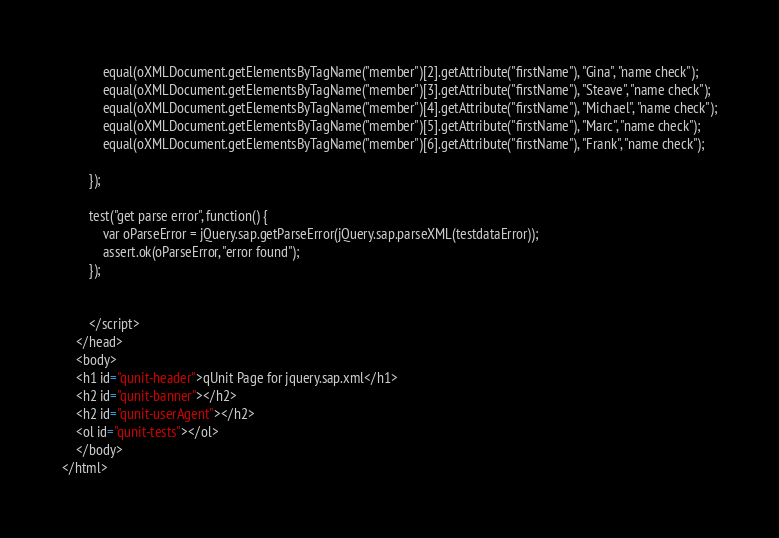<code> <loc_0><loc_0><loc_500><loc_500><_HTML_>			equal(oXMLDocument.getElementsByTagName("member")[2].getAttribute("firstName"), "Gina", "name check");
			equal(oXMLDocument.getElementsByTagName("member")[3].getAttribute("firstName"), "Steave", "name check");
			equal(oXMLDocument.getElementsByTagName("member")[4].getAttribute("firstName"), "Michael", "name check");
			equal(oXMLDocument.getElementsByTagName("member")[5].getAttribute("firstName"), "Marc", "name check");
			equal(oXMLDocument.getElementsByTagName("member")[6].getAttribute("firstName"), "Frank", "name check");

		});

		test("get parse error", function() {
			var oParseError = jQuery.sap.getParseError(jQuery.sap.parseXML(testdataError));
			assert.ok(oParseError, "error found");
		});


    	</script>
	</head>
	<body>
    <h1 id="qunit-header">qUnit Page for jquery.sap.xml</h1>
    <h2 id="qunit-banner"></h2>
    <h2 id="qunit-userAgent"></h2>
    <ol id="qunit-tests"></ol>
	</body>
</html>
</code> 